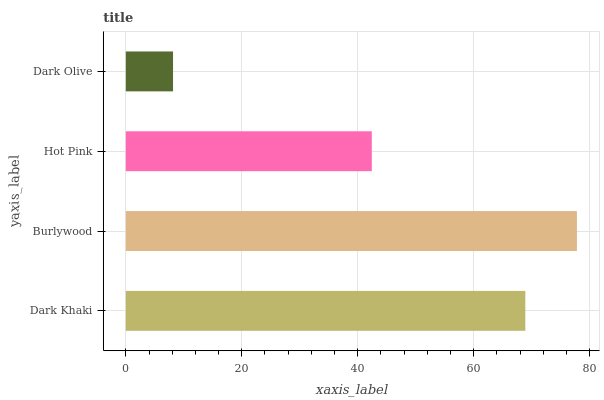Is Dark Olive the minimum?
Answer yes or no. Yes. Is Burlywood the maximum?
Answer yes or no. Yes. Is Hot Pink the minimum?
Answer yes or no. No. Is Hot Pink the maximum?
Answer yes or no. No. Is Burlywood greater than Hot Pink?
Answer yes or no. Yes. Is Hot Pink less than Burlywood?
Answer yes or no. Yes. Is Hot Pink greater than Burlywood?
Answer yes or no. No. Is Burlywood less than Hot Pink?
Answer yes or no. No. Is Dark Khaki the high median?
Answer yes or no. Yes. Is Hot Pink the low median?
Answer yes or no. Yes. Is Dark Olive the high median?
Answer yes or no. No. Is Dark Khaki the low median?
Answer yes or no. No. 